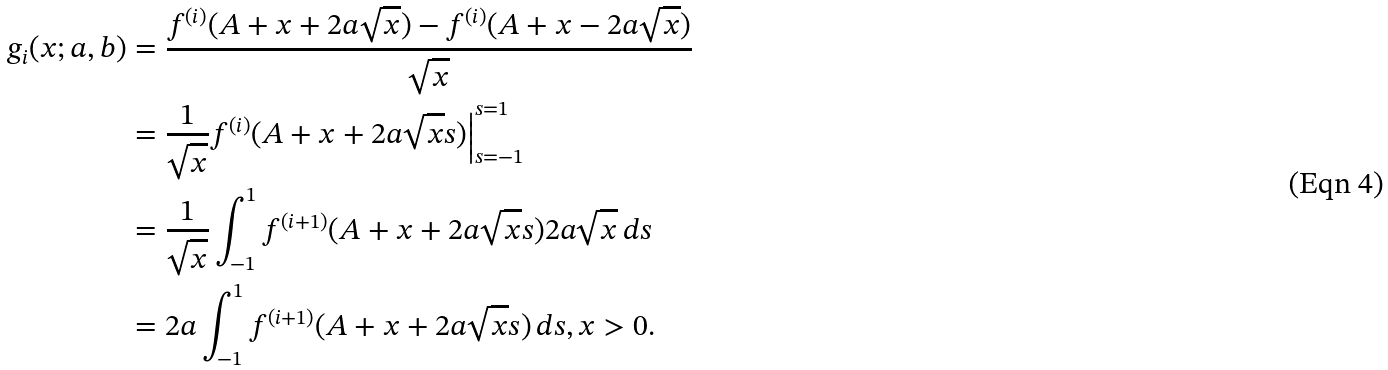<formula> <loc_0><loc_0><loc_500><loc_500>g _ { i } ( x ; a , b ) & = \frac { f ^ { ( i ) } ( A + x + 2 a \sqrt { x } ) - f ^ { ( i ) } ( A + x - 2 a \sqrt { x } ) } { \sqrt { x } } \\ & = \frac { 1 } { \sqrt { x } } f ^ { ( i ) } ( A + x + 2 a \sqrt { x } s ) \Big | _ { s = - 1 } ^ { s = 1 } \\ & = \frac { 1 } { \sqrt { x } } \int _ { - 1 } ^ { 1 } f ^ { ( i + 1 ) } ( A + x + 2 a \sqrt { x } s ) 2 a \sqrt { x } \, d s \\ & = 2 a \int _ { - 1 } ^ { 1 } f ^ { ( i + 1 ) } ( A + x + 2 a \sqrt { x } s ) \, d s , x > 0 .</formula> 